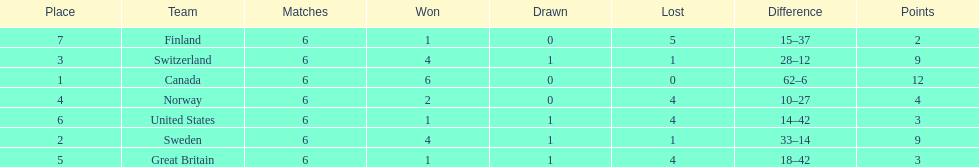During the 1951 world ice hockey championships, what was the difference between the first and last place teams for number of games won ? 5. 